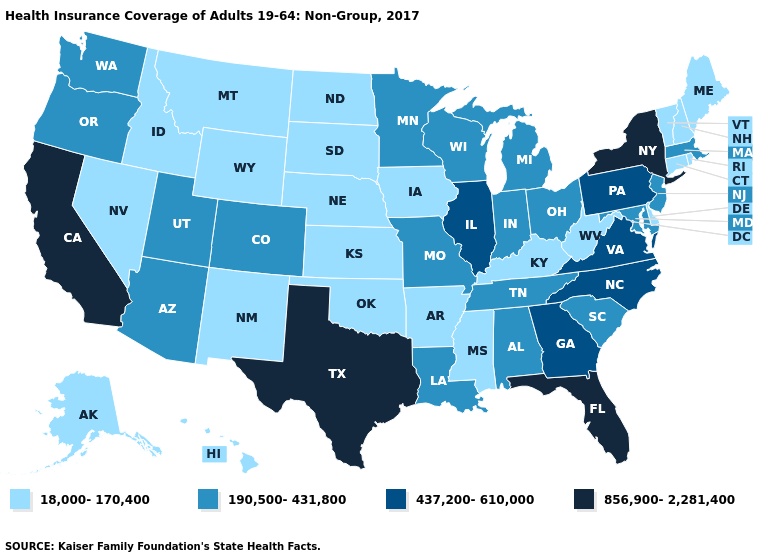What is the value of California?
Be succinct. 856,900-2,281,400. What is the lowest value in states that border Indiana?
Answer briefly. 18,000-170,400. Among the states that border Maryland , which have the lowest value?
Quick response, please. Delaware, West Virginia. Does Washington have the lowest value in the West?
Keep it brief. No. What is the value of New Mexico?
Keep it brief. 18,000-170,400. Which states have the lowest value in the USA?
Answer briefly. Alaska, Arkansas, Connecticut, Delaware, Hawaii, Idaho, Iowa, Kansas, Kentucky, Maine, Mississippi, Montana, Nebraska, Nevada, New Hampshire, New Mexico, North Dakota, Oklahoma, Rhode Island, South Dakota, Vermont, West Virginia, Wyoming. Does the map have missing data?
Quick response, please. No. Does the map have missing data?
Write a very short answer. No. Does the first symbol in the legend represent the smallest category?
Write a very short answer. Yes. Among the states that border Alabama , which have the highest value?
Quick response, please. Florida. Does the first symbol in the legend represent the smallest category?
Short answer required. Yes. Among the states that border Colorado , does Arizona have the lowest value?
Write a very short answer. No. Name the states that have a value in the range 18,000-170,400?
Give a very brief answer. Alaska, Arkansas, Connecticut, Delaware, Hawaii, Idaho, Iowa, Kansas, Kentucky, Maine, Mississippi, Montana, Nebraska, Nevada, New Hampshire, New Mexico, North Dakota, Oklahoma, Rhode Island, South Dakota, Vermont, West Virginia, Wyoming. Among the states that border North Carolina , does South Carolina have the highest value?
Give a very brief answer. No. Name the states that have a value in the range 437,200-610,000?
Concise answer only. Georgia, Illinois, North Carolina, Pennsylvania, Virginia. 